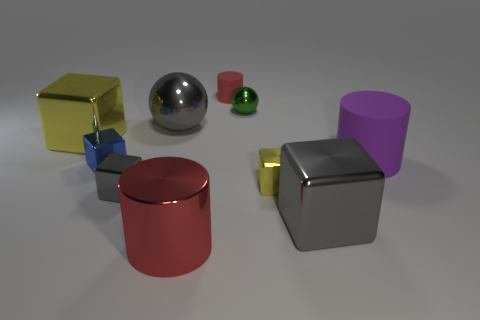Are there fewer cylinders in front of the gray ball than tiny green shiny balls?
Ensure brevity in your answer.  No. Do the blue object and the large matte object have the same shape?
Offer a terse response. No. There is a rubber thing that is behind the tiny green object; what is its size?
Provide a succinct answer. Small. There is a cylinder that is made of the same material as the blue object; what is its size?
Your answer should be compact. Large. Is the number of cyan rubber cylinders less than the number of metallic cylinders?
Your answer should be very brief. Yes. There is another purple cylinder that is the same size as the metallic cylinder; what material is it?
Offer a very short reply. Rubber. Is the number of small cyan metallic balls greater than the number of small cubes?
Provide a short and direct response. No. How many other objects are the same color as the big metal ball?
Your answer should be compact. 2. How many things are both in front of the green thing and to the right of the big ball?
Provide a short and direct response. 4. Are there any other things that are the same size as the green shiny object?
Your answer should be very brief. Yes. 